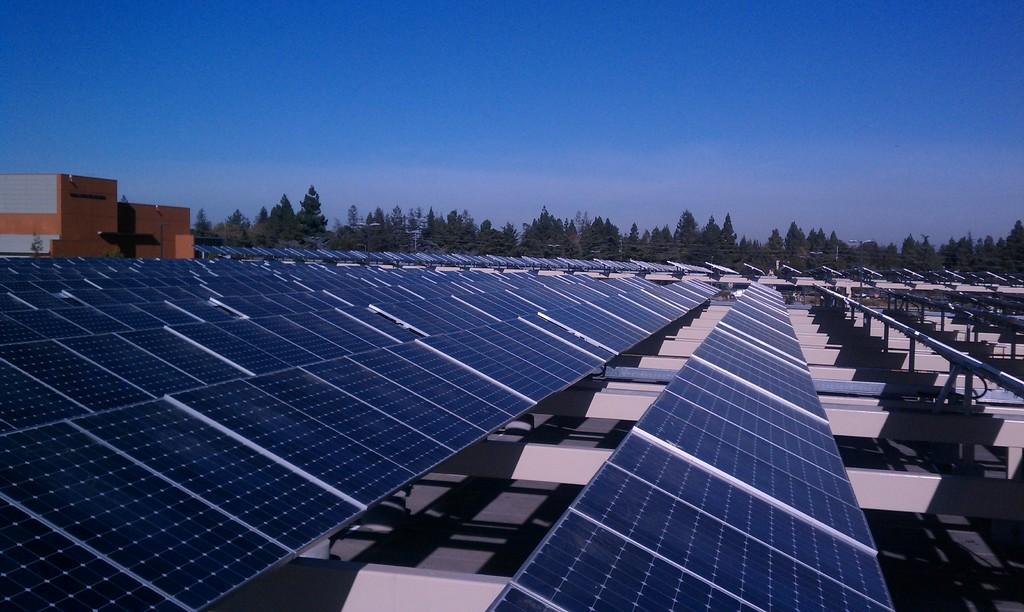What type of energy-producing devices are present in the image? There are solar panels in the image. What color are the objects on the left side of the image? The objects on the left side of the image are orange. What can be seen in the distance in the image? There are trees visible in the background of the image. What rule is being enforced by the tin object in the image? There is no tin object present in the image, and therefore no rule enforcement can be observed. 